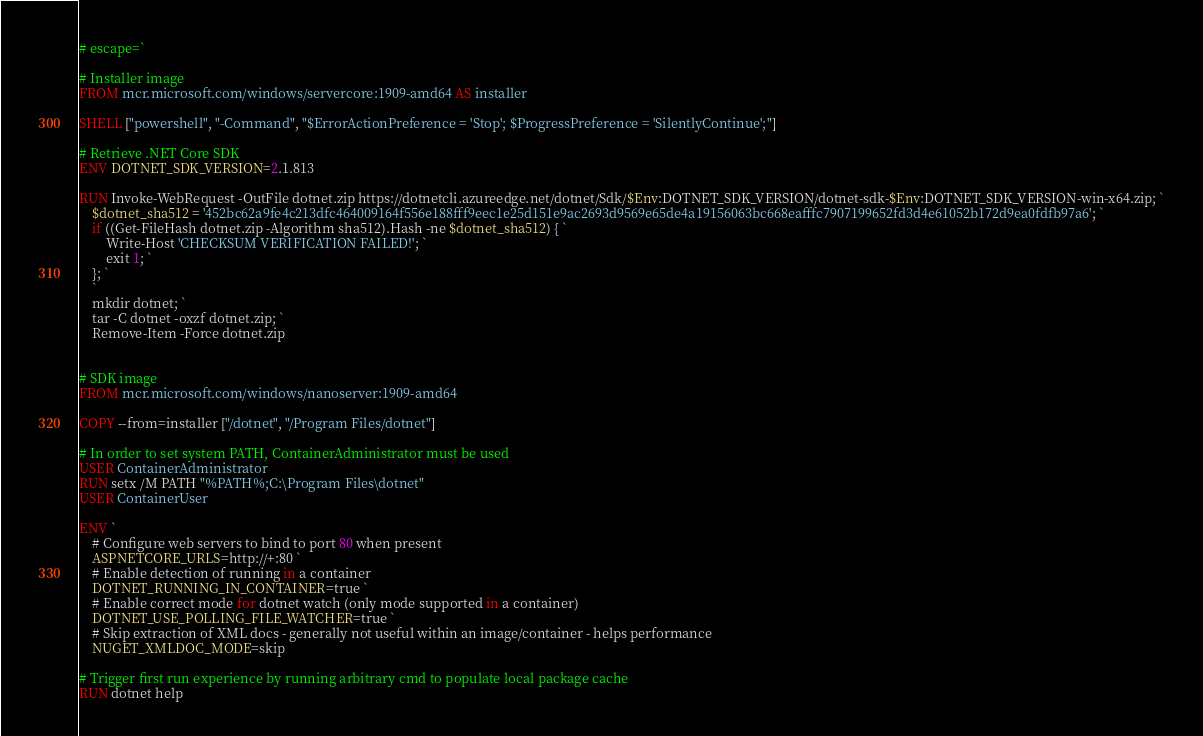Convert code to text. <code><loc_0><loc_0><loc_500><loc_500><_Dockerfile_># escape=`

# Installer image
FROM mcr.microsoft.com/windows/servercore:1909-amd64 AS installer

SHELL ["powershell", "-Command", "$ErrorActionPreference = 'Stop'; $ProgressPreference = 'SilentlyContinue';"]

# Retrieve .NET Core SDK
ENV DOTNET_SDK_VERSION=2.1.813

RUN Invoke-WebRequest -OutFile dotnet.zip https://dotnetcli.azureedge.net/dotnet/Sdk/$Env:DOTNET_SDK_VERSION/dotnet-sdk-$Env:DOTNET_SDK_VERSION-win-x64.zip; `
    $dotnet_sha512 = '452bc62a9fe4c213dfc464009164f556e188fff9eec1e25d151e9ac2693d9569e65de4a19156063bc668eafffc7907199652fd3d4e61052b172d9ea0fdfb97a6'; `
    if ((Get-FileHash dotnet.zip -Algorithm sha512).Hash -ne $dotnet_sha512) { `
        Write-Host 'CHECKSUM VERIFICATION FAILED!'; `
        exit 1; `
    }; `
    `
    mkdir dotnet; `
    tar -C dotnet -oxzf dotnet.zip; `
    Remove-Item -Force dotnet.zip


# SDK image
FROM mcr.microsoft.com/windows/nanoserver:1909-amd64

COPY --from=installer ["/dotnet", "/Program Files/dotnet"]

# In order to set system PATH, ContainerAdministrator must be used
USER ContainerAdministrator
RUN setx /M PATH "%PATH%;C:\Program Files\dotnet"
USER ContainerUser

ENV `
    # Configure web servers to bind to port 80 when present
    ASPNETCORE_URLS=http://+:80 `
    # Enable detection of running in a container
    DOTNET_RUNNING_IN_CONTAINER=true `
    # Enable correct mode for dotnet watch (only mode supported in a container)
    DOTNET_USE_POLLING_FILE_WATCHER=true `
    # Skip extraction of XML docs - generally not useful within an image/container - helps performance
    NUGET_XMLDOC_MODE=skip

# Trigger first run experience by running arbitrary cmd to populate local package cache
RUN dotnet help
</code> 